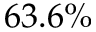Convert formula to latex. <formula><loc_0><loc_0><loc_500><loc_500>6 3 . 6 \%</formula> 